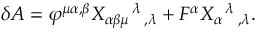<formula> <loc_0><loc_0><loc_500><loc_500>\delta A = \varphi ^ { \mu \alpha , \beta } X _ { \alpha \beta \mu ^ { \, \lambda _ { \, , \lambda } + F ^ { \alpha } X _ { \alpha ^ { \, \lambda _ { \, , \lambda } .</formula> 